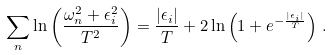<formula> <loc_0><loc_0><loc_500><loc_500>\sum _ { n } \ln \left ( \frac { \omega _ { n } ^ { 2 } + \epsilon _ { i } ^ { 2 } } { T ^ { 2 } } \right ) = \frac { | \epsilon _ { i } | } { T } + 2 \ln \left ( 1 + e ^ { - \frac { | \epsilon _ { i } | } { T } } \right ) \, .</formula> 